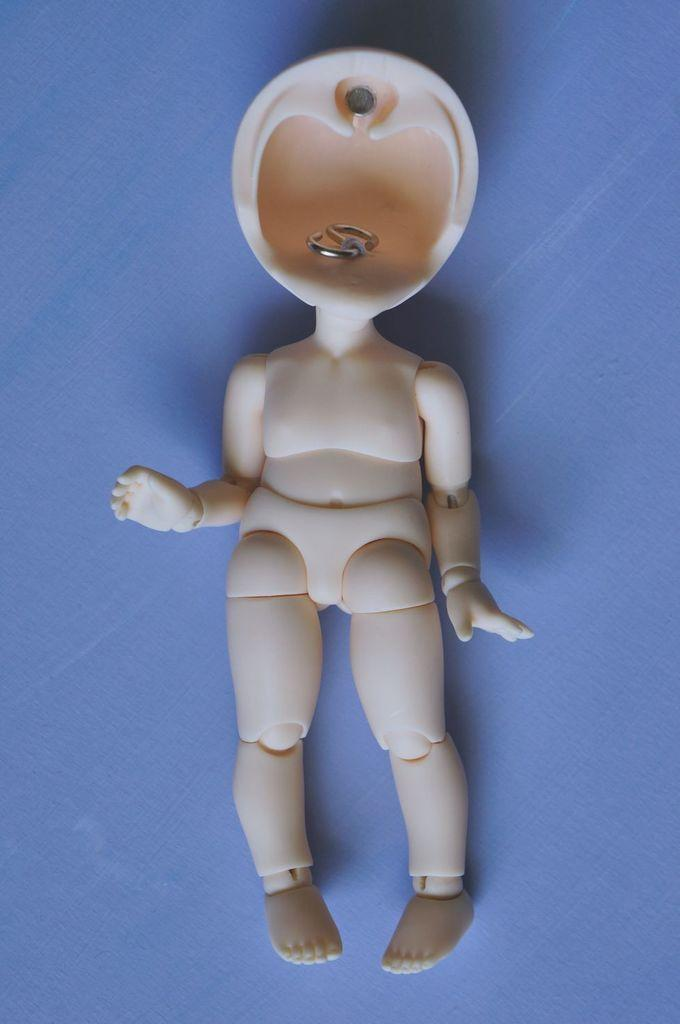What is the main subject in the center of the image? There is a toy of a person in the image, and it is in the center. What is the color of the object that the toy is placed on? The object appears to be a table, and it is blue. Can you see any ghosts interacting with the toy in the image? There are no ghosts present in the image. What type of clouds can be seen in the background of the image? There is no background or clouds visible in the image; it only shows the toy and the blue table. 